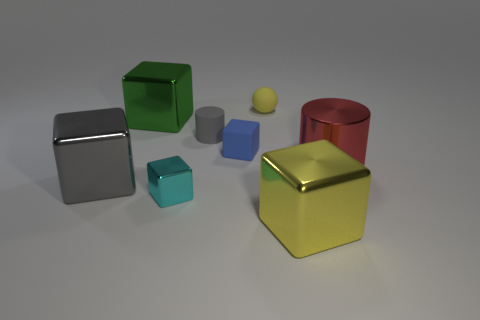What number of large cylinders are the same color as the tiny sphere?
Provide a short and direct response. 0. How many small objects are either yellow metal cubes or cylinders?
Offer a terse response. 1. The thing that is the same color as the tiny matte sphere is what size?
Offer a very short reply. Large. Are there any big yellow cubes that have the same material as the green object?
Offer a very short reply. Yes. There is a yellow object behind the cyan metallic block; what is its material?
Your answer should be very brief. Rubber. There is a small block in front of the big red metal thing; is it the same color as the tiny cube right of the gray cylinder?
Keep it short and to the point. No. There is a ball that is the same size as the blue object; what is its color?
Provide a succinct answer. Yellow. How many other objects are the same shape as the red thing?
Offer a very short reply. 1. What is the size of the matte object to the left of the matte cube?
Provide a short and direct response. Small. What number of blue blocks are in front of the small matte object left of the blue block?
Offer a terse response. 1. 